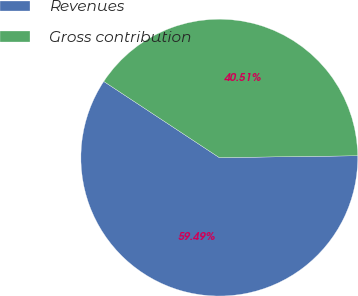Convert chart to OTSL. <chart><loc_0><loc_0><loc_500><loc_500><pie_chart><fcel>Revenues<fcel>Gross contribution<nl><fcel>59.49%<fcel>40.51%<nl></chart> 